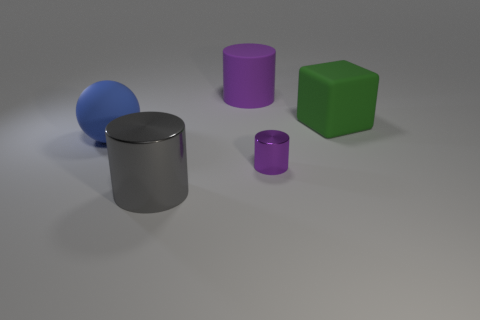Add 4 large cylinders. How many objects exist? 9 Subtract all spheres. How many objects are left? 4 Subtract all big green rubber blocks. Subtract all large blue matte balls. How many objects are left? 3 Add 2 big purple matte cylinders. How many big purple matte cylinders are left? 3 Add 3 large spheres. How many large spheres exist? 4 Subtract 0 red spheres. How many objects are left? 5 